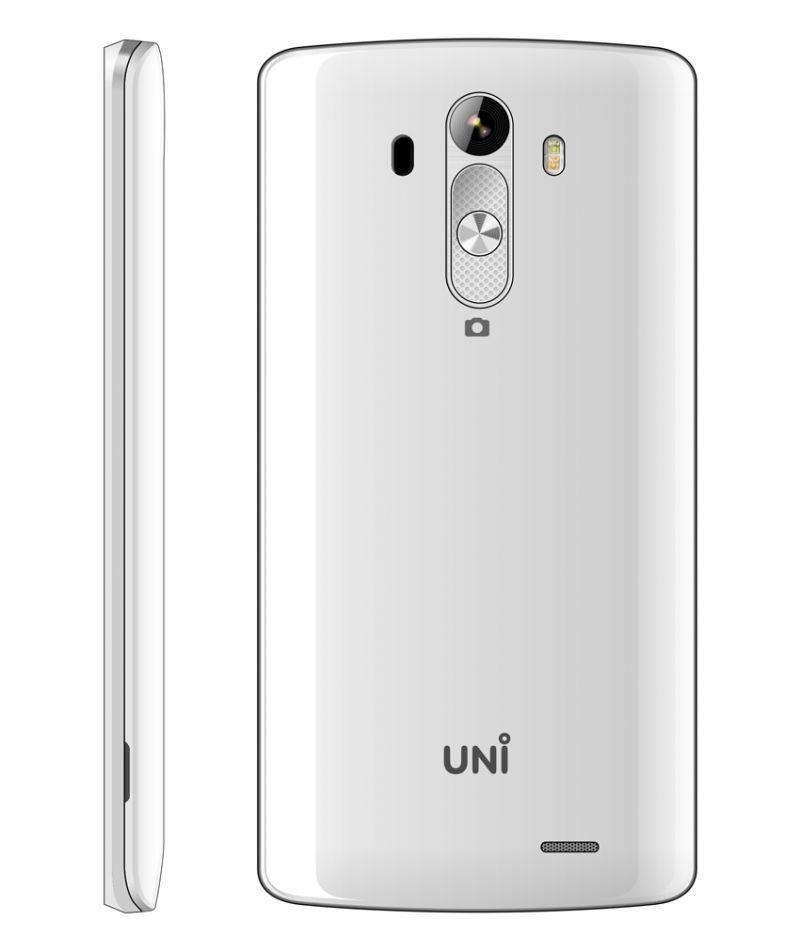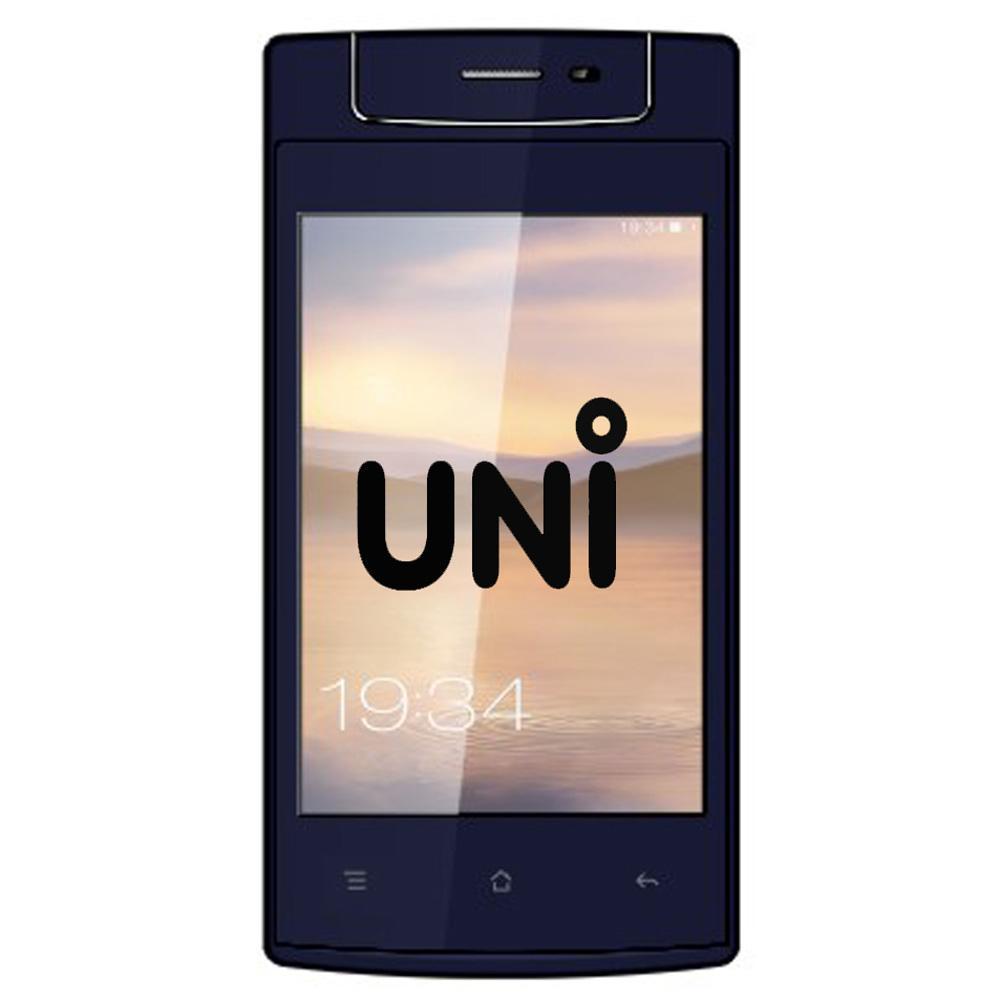The first image is the image on the left, the second image is the image on the right. For the images displayed, is the sentence "Twenty one or more physical buttons are visible." factually correct? Answer yes or no. No. 